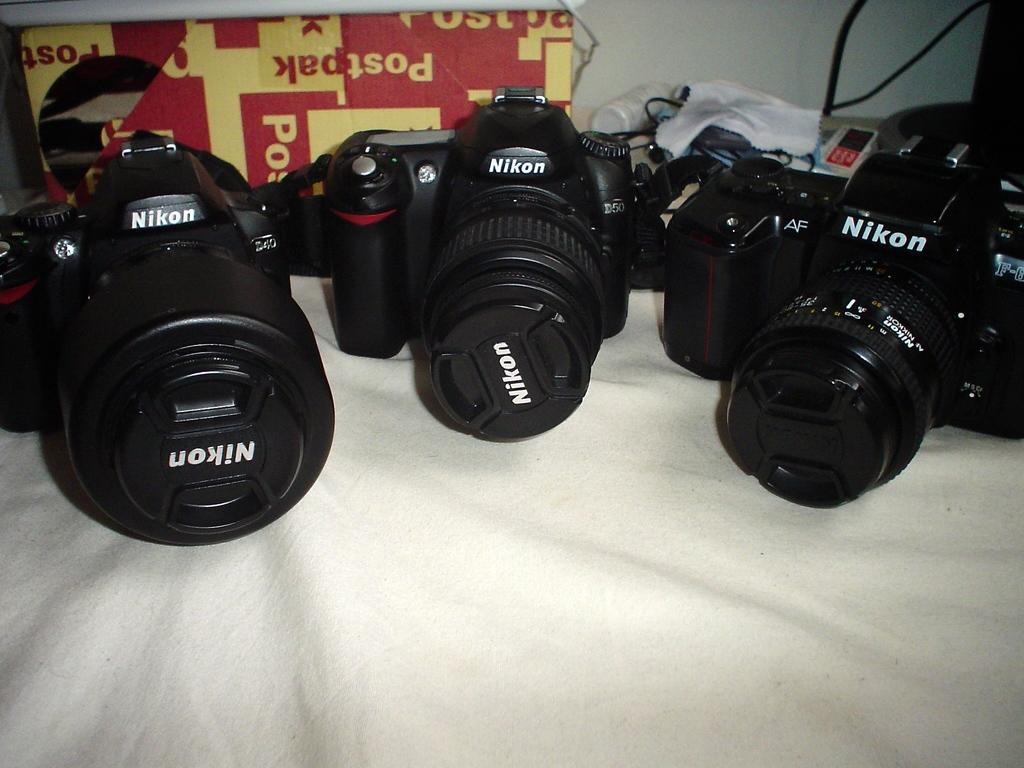How many cameras are visible in the image? There are three cameras in the image. What is the color of the cameras? The cameras are black in color. Where are the cameras placed? The cameras are placed on a white colored cloth. What can be seen in the background of the image? There is a red and yellow colored object and a white colored wall in the background. Can you touch the beef in the image? There is no beef present in the image. How many steps are required to reach the cameras in the image? The image does not provide information about the distance or steps required to reach the cameras. 